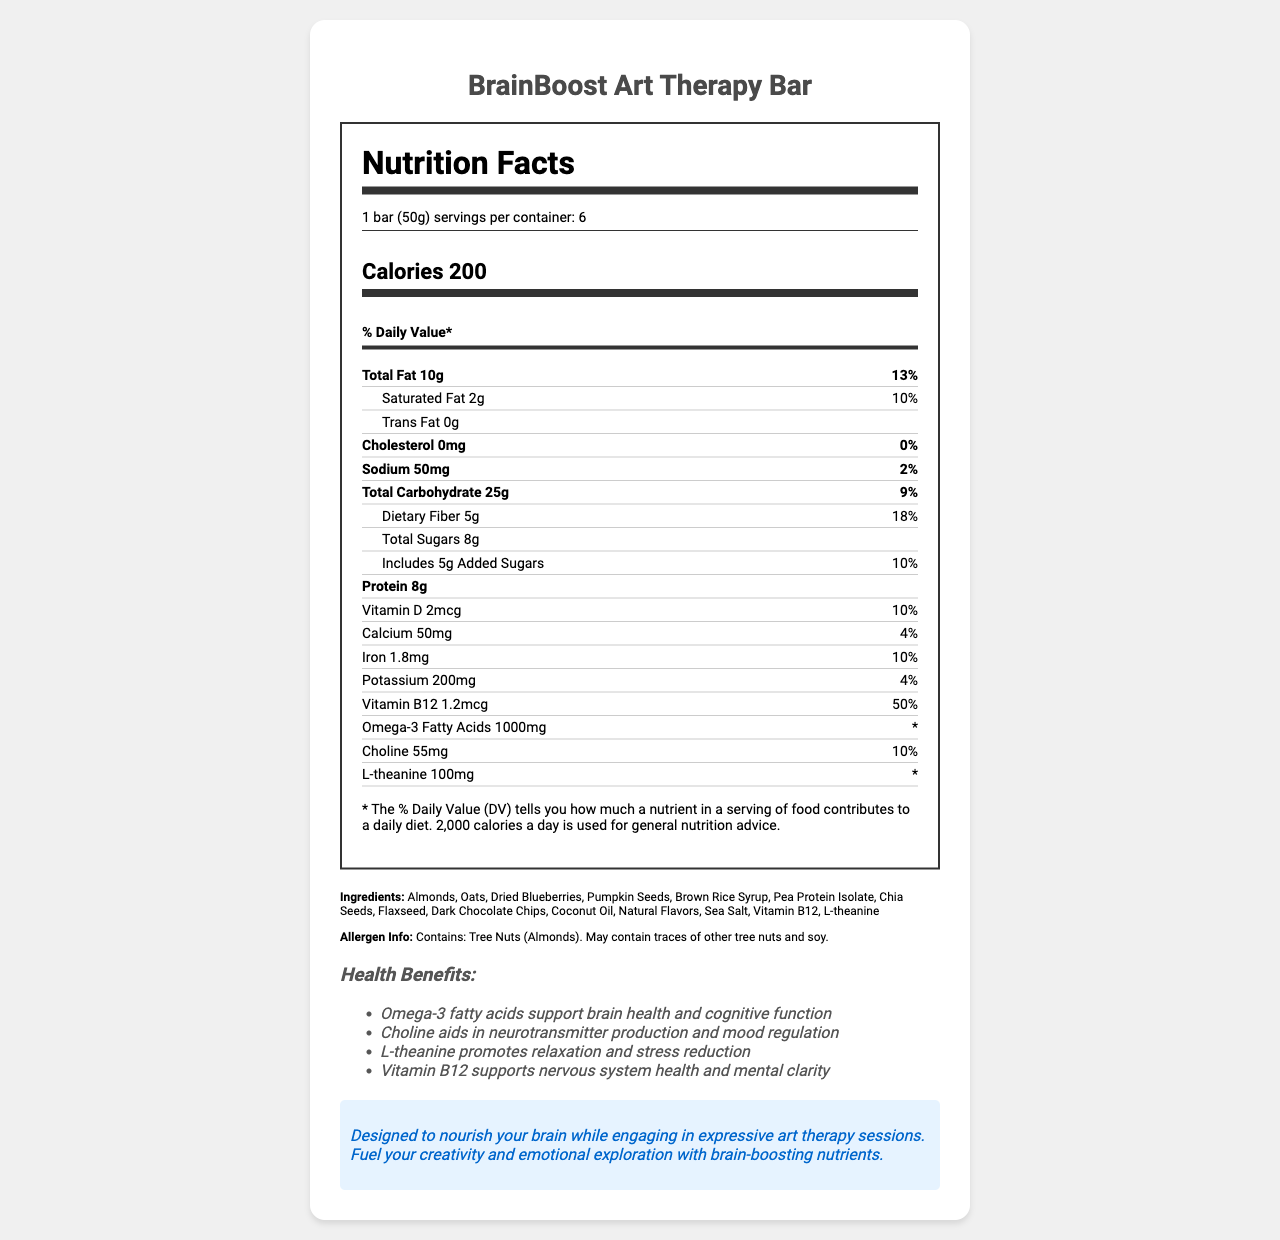what is the serving size for the BrainBoost Art Therapy Bar? The serving size is clearly stated at the top of the Nutrition Facts label as "1 bar (50g)."
Answer: 1 bar (50g) how many servings are in each container? The label specifies that there are 6 servings per container.
Answer: 6 what is the total fat content per serving? The total fat content is listed as "Total Fat 10g" under the nutrient rows.
Answer: 10g what percentage of the daily value for dietary fiber does the BrainBoost Art Therapy Bar provide? The document states that the dietary fiber content is 5g, which is 18% of the daily value.
Answer: 18% how much protein does one BrainBoost Art Therapy Bar contain? The protein content is clearly listed as 8g under the nutrient rows.
Answer: 8g which nutrient has the highest percentage of daily value in this snack bar? A. Vitamin D B. Iron C. Vitamin B12 D. Potassium Vitamin B12 has 50% of the daily value, which is the highest among the listed nutrients.
Answer: C. Vitamin B12 how many grams of added sugars are in a serving? A. 2g B. 5g C. 8g D. 10g The label shows "Includes 5g Added Sugars" under the total carbohydrate section.
Answer: B. 5g does this bar contain any cholesterol? The document states that the cholesterol content is 0mg, which corresponds to 0% of the daily value.
Answer: No summarize the main purpose and benefits of the BrainBoost Art Therapy Bar. The summary captures the overall goal of combining brain-boosting nutrition with art therapy, highlighting the main nutrients and their benefits. The explanation provides a detailed description of the bar's purpose and its connection to art therapy.
Answer: The BrainBoost Art Therapy Bar is designed to provide cognitive-enhancing nutrients that support brain health and function. It contains ingredients like omega-3 fatty acids, choline, L-theanine, and Vitamin B12, which contribute to improved brain performance, mood regulation, relaxation, and stress reduction. This snack bar is intended to nourish the brain while engaging in expressive art therapy sessions, enhancing creativity and emotional exploration. what is the main benefit of omega-3 fatty acids listed on the label? The health claims section lists that omega-3 fatty acids support brain health and cognitive function.
Answer: Supports brain health and cognitive function does the BrainBoost Art Therapy Bar contain ingredients that can cause allergic reactions? The allergen information states that the bar contains tree nuts (almonds) and may contain traces of other tree nuts and soy.
Answer: Yes what is the calorie count for one serving of the BrainBoost Art Therapy Bar? The calorie count is prominently displayed under the calorie information section.
Answer: 200 calories can the BrainBoost Art Therapy Bar be classified as a low-sodium food? The sodium content is 50mg, which is 2% of the daily value, not particularly low but not high either.
Answer: No how much choline is present in a serving? The amount of choline per serving is listed as 55mg.
Answer: 55mg is there any information about the manufacturing process or facility for the BrainBoost Art Therapy Bar in the document? The document does not provide any details about the manufacturing process or facility.
Answer: Not enough information would consuming this bar contribute significantly to an individual's daily vitamin B12 intake? One bar provides 50% of the daily value for vitamin B12, which is a significant contribution.
Answer: Yes 